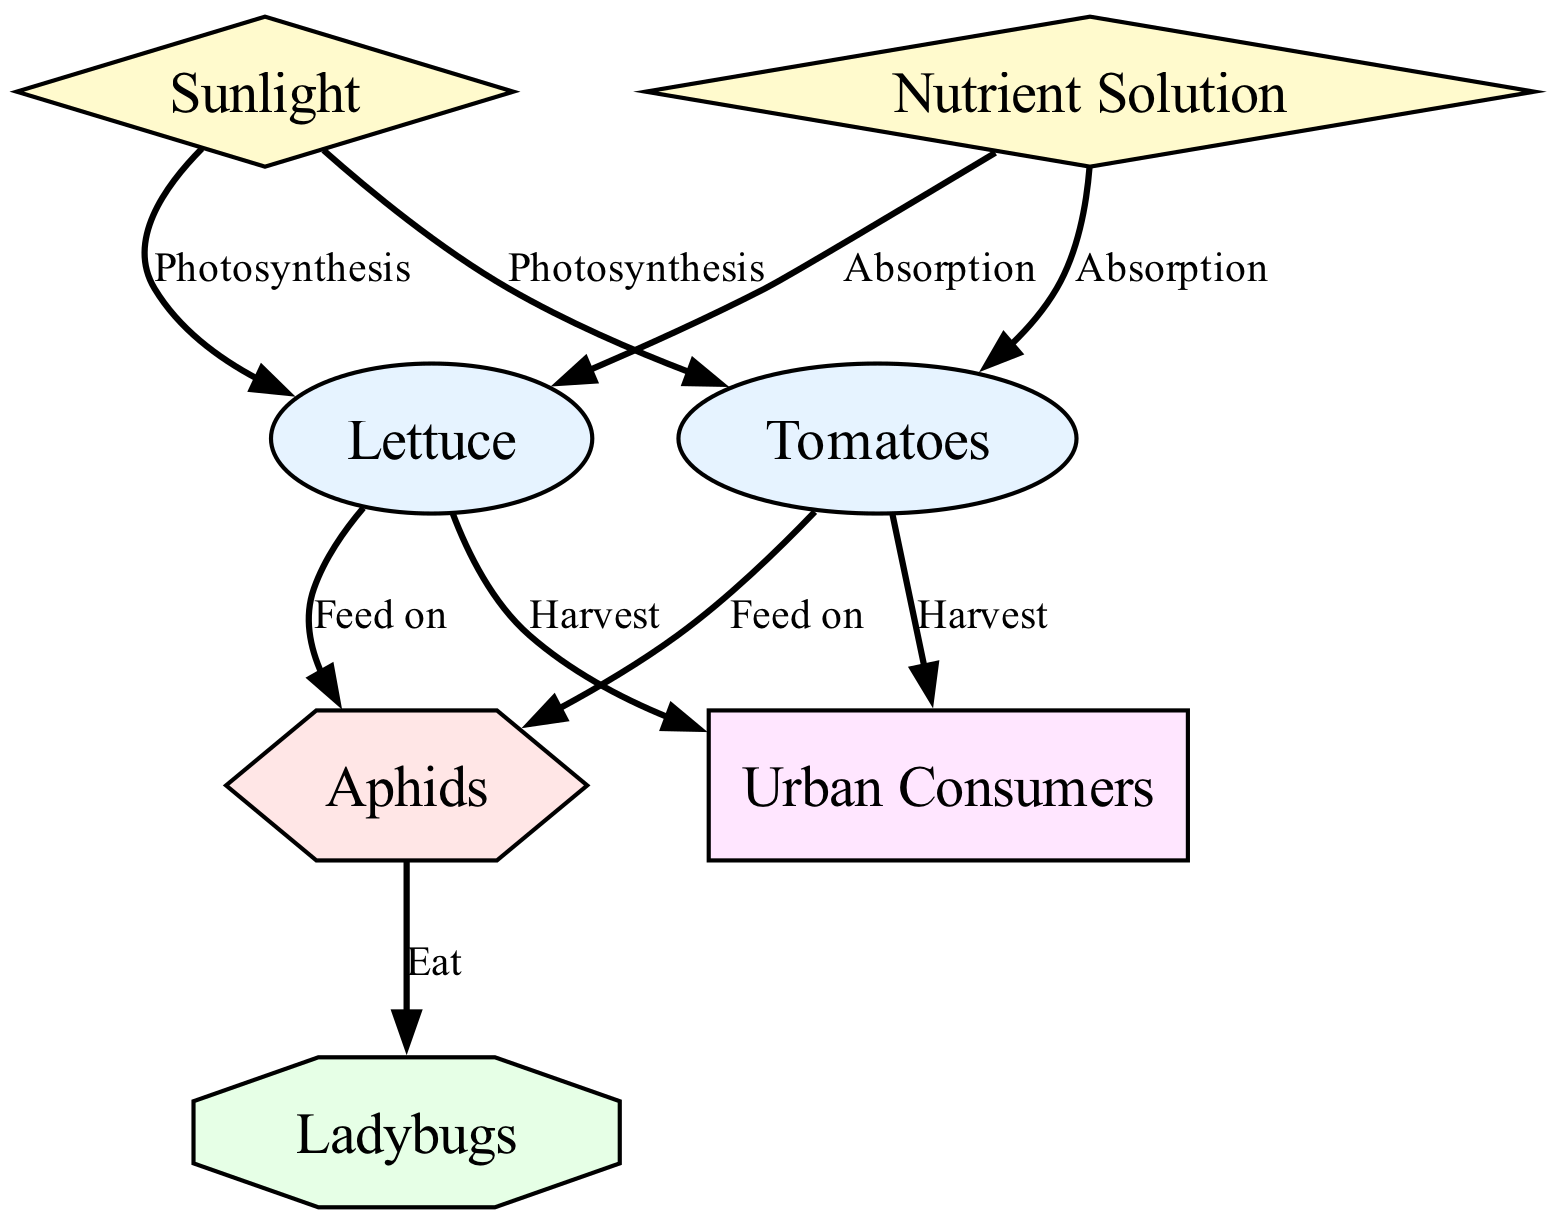What is the main nutrient for the plants? The diagram indicates "Nutrient Solution" as a producer, which provides essential nutrients for the plants in a hydroponic garden.
Answer: Nutrient Solution Which type of consumers are aphids? In the food chain diagram, aphids are classified as secondary consumers, which means they feed on primary consumers like lettuce and tomatoes.
Answer: Secondary Consumer How many primary consumers are depicted in the diagram? By counting the nodes labeled as primary consumers, the diagram shows two primary consumers: lettuce and tomatoes.
Answer: 2 What do ladybugs eat? The diagram shows a direct relationship where ladybugs eat aphids, indicating that they rely on them for food.
Answer: Aphids How do humans interact with lettuce? According to the diagram, the relationship is noted as "Harvest," indicating that humans collect or harvest lettuce for consumption.
Answer: Harvest Which two producers are involved in the food chain? The diagram identifies sunlight and nutrient solution as the two main producers, both of which contribute to the growth of the plants.
Answer: Sunlight and Nutrient Solution What is the relationship between sunlight and tomatoes? The diagram shows a direct relationship described as "Photosynthesis," highlighting how tomatoes utilize sunlight for growth.
Answer: Photosynthesis Identifying the top consumer in the food chain, who is it? The diagram classifies "Urban Consumers" as the top consumer, as they harvest and consume the primary products of the garden.
Answer: Urban Consumers What process allows lettuce to absorb nutrients? The diagram details the relationship as "Absorption," which illustrates how lettuce takes in nutrients from the nutrient solution.
Answer: Absorption 